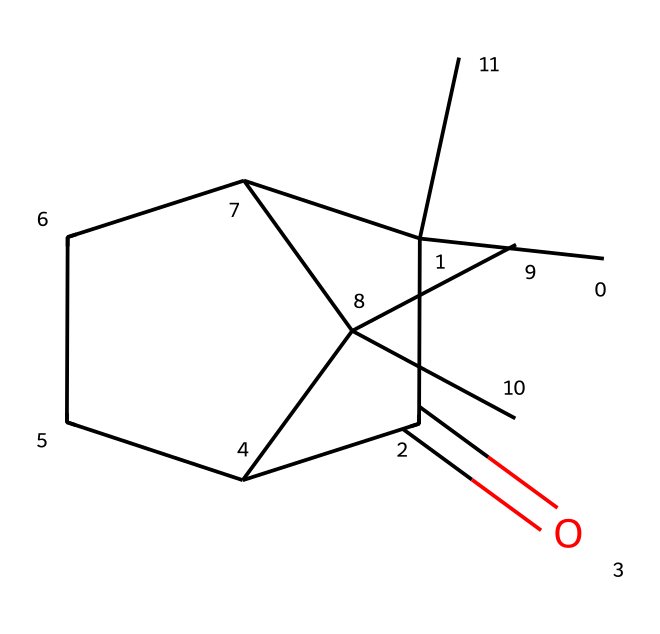What is the molecular formula of camphor? The SMILES representation indicates the presence of 10 carbon atoms (C), 16 hydrogen atoms (H), and 1 oxygen atom (O), leading to the molecular formula C10H16O.
Answer: C10H16O How many rings are present in the structure of camphor? By analyzing the SMILES representation, there are two cyclic components indicated by the numbers '1' and '2', which suggest two rings in the structure.
Answer: 2 What type of functional group is present in camphor? The presence of the carbonyl group (C=O) indicates that camphor belongs to the ketone functional group, which is characterized by the carbonyl carbon being bound to two other carbon atoms.
Answer: ketone How many chiral centers does camphor have? In the structure, there are two carbon atoms bonded to four different groups, leading to two chiral centers in camphor, as inferred from the non-symmetrical arrangement.
Answer: 2 What is the main use of camphor? Camphor is primarily used in medicinal applications, especially in cough suppressants due to its soothing and cough-relieving properties.
Answer: cough suppressant Is camphor a saturated or unsaturated compound? The SMILES representation indicates no double bonds between carbon atoms apart from the carbonyl, suggesting that camphor is a saturated compound overall, characterized by single bonds across most of its structure.
Answer: saturated 